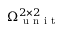Convert formula to latex. <formula><loc_0><loc_0><loc_500><loc_500>\Omega _ { u n i t } ^ { 2 \times 2 }</formula> 